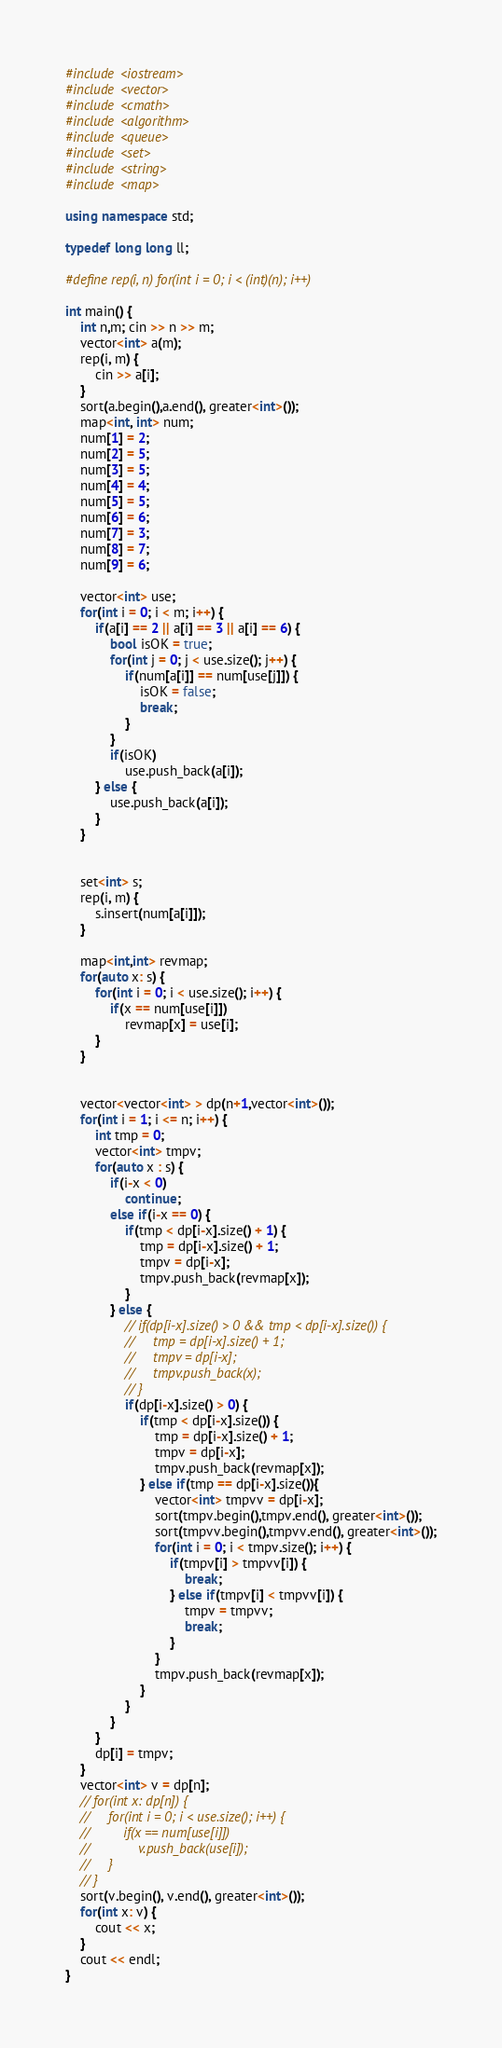Convert code to text. <code><loc_0><loc_0><loc_500><loc_500><_C++_>#include <iostream>
#include <vector>
#include <cmath>
#include <algorithm>
#include <queue>
#include <set>
#include <string>
#include <map>

using namespace std;

typedef long long ll;

#define rep(i, n) for(int i = 0; i < (int)(n); i++)

int main() {
    int n,m; cin >> n >> m;
    vector<int> a(m);
    rep(i, m) {
        cin >> a[i];
    }
    sort(a.begin(),a.end(), greater<int>());
    map<int, int> num;
    num[1] = 2;
    num[2] = 5;
    num[3] = 5;
    num[4] = 4;
    num[5] = 5;
    num[6] = 6;
    num[7] = 3;
    num[8] = 7;
    num[9] = 6;

    vector<int> use;
    for(int i = 0; i < m; i++) {
        if(a[i] == 2 || a[i] == 3 || a[i] == 6) {
            bool isOK = true;
            for(int j = 0; j < use.size(); j++) {
                if(num[a[i]] == num[use[j]]) {
                    isOK = false;
                    break;
                }
            }
            if(isOK)
                use.push_back(a[i]);
        } else {
            use.push_back(a[i]);
        }
    }


    set<int> s;
    rep(i, m) {
        s.insert(num[a[i]]);
    }

    map<int,int> revmap;
    for(auto x: s) {
        for(int i = 0; i < use.size(); i++) {
            if(x == num[use[i]])
                revmap[x] = use[i];
        }
    }


    vector<vector<int> > dp(n+1,vector<int>());
    for(int i = 1; i <= n; i++) {
        int tmp = 0;
        vector<int> tmpv;
        for(auto x : s) {
            if(i-x < 0)
                continue;
            else if(i-x == 0) {
                if(tmp < dp[i-x].size() + 1) {
                    tmp = dp[i-x].size() + 1;
                    tmpv = dp[i-x];
                    tmpv.push_back(revmap[x]);
                }
            } else {
                // if(dp[i-x].size() > 0 && tmp < dp[i-x].size()) {
                //     tmp = dp[i-x].size() + 1;
                //     tmpv = dp[i-x];
                //     tmpv.push_back(x);
                // }
                if(dp[i-x].size() > 0) {
                    if(tmp < dp[i-x].size()) {
                        tmp = dp[i-x].size() + 1;
                        tmpv = dp[i-x];
                        tmpv.push_back(revmap[x]);
                    } else if(tmp == dp[i-x].size()){
                        vector<int> tmpvv = dp[i-x];
                        sort(tmpv.begin(),tmpv.end(), greater<int>());
                        sort(tmpvv.begin(),tmpvv.end(), greater<int>());
                        for(int i = 0; i < tmpv.size(); i++) {
                            if(tmpv[i] > tmpvv[i]) {
                                break;
                            } else if(tmpv[i] < tmpvv[i]) {
                                tmpv = tmpvv;
                                break;
                            }
                        }
                        tmpv.push_back(revmap[x]);
                    }
                }
            }
        }
        dp[i] = tmpv;
    }
    vector<int> v = dp[n];
    // for(int x: dp[n]) {
    //     for(int i = 0; i < use.size(); i++) {
    //         if(x == num[use[i]])
    //             v.push_back(use[i]);
    //     }
    // }
    sort(v.begin(), v.end(), greater<int>());
    for(int x: v) {
        cout << x;
    }
    cout << endl;
}
</code> 